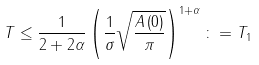<formula> <loc_0><loc_0><loc_500><loc_500>T \leq \frac { 1 } { 2 + 2 \alpha } \left ( \frac { 1 } { \sigma } \sqrt { \frac { A \left ( 0 \right ) } { \pi } } \right ) ^ { 1 + \alpha } \colon = T _ { 1 }</formula> 